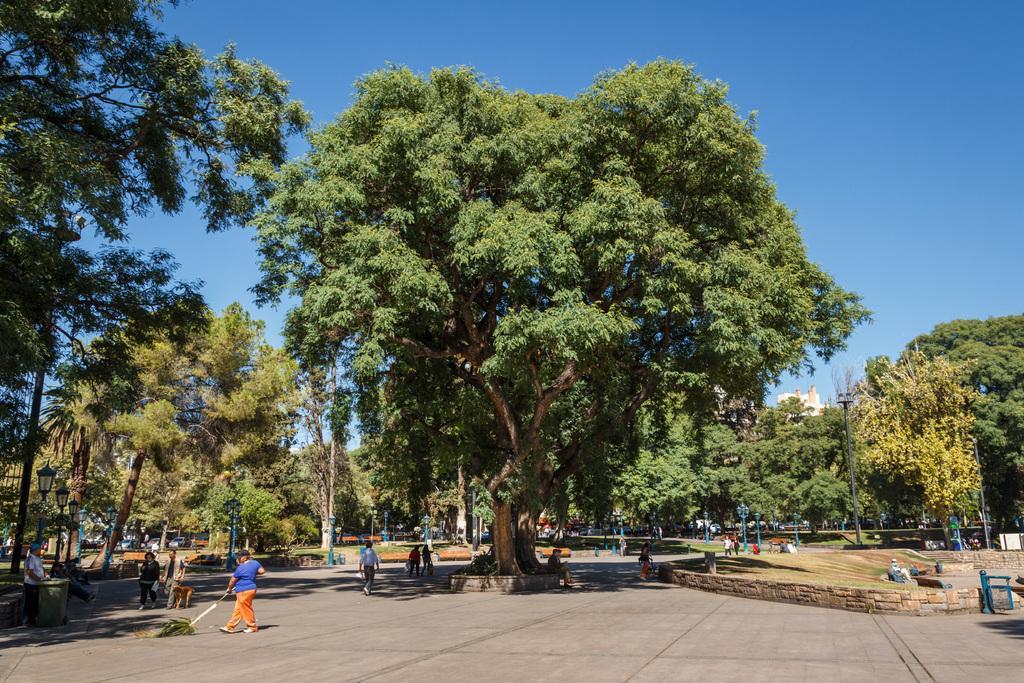Please provide a concise description of this image. There are persons on the road. There are trees and grass on the ground. In the background, there is blue sky. 